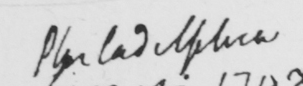What does this handwritten line say? Philadelphia 